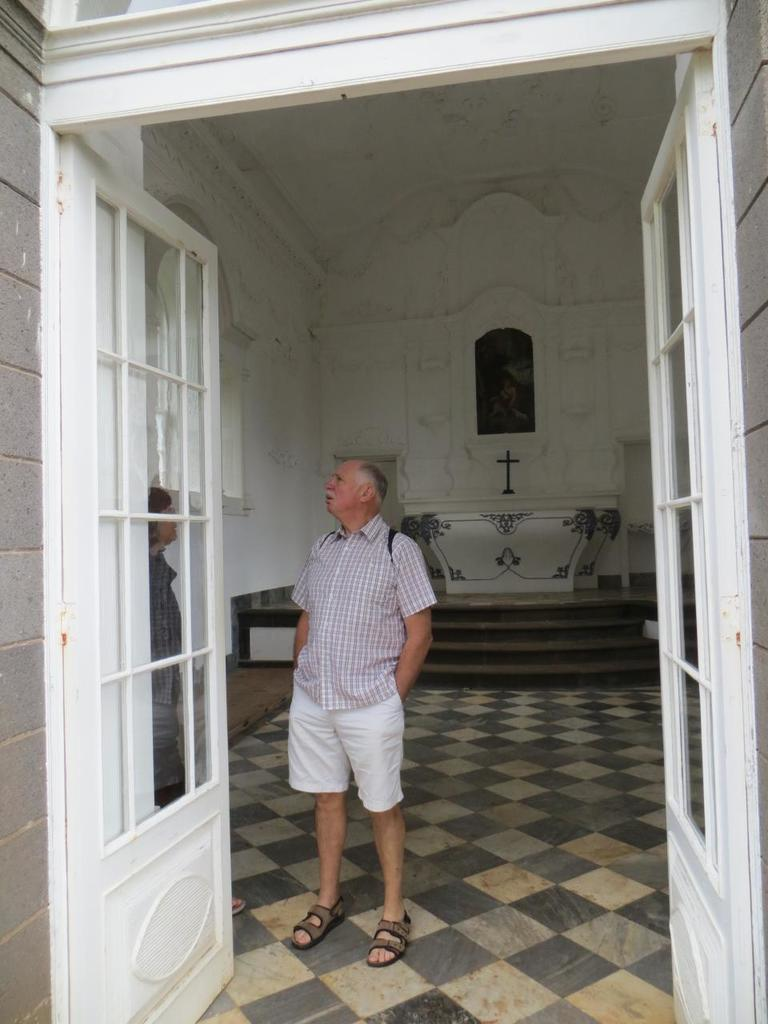What is the main subject of the image? The main subject of the image is the persons standing in the center. What can be seen in the background of the image? In the background of the image, there is a cross, a wall, a table, and a window. Can you describe the foreground of the image? In the foreground of the image, there is a door. How many kittens are sitting on the table in the image? There are no kittens present in the image. Is the queen sitting with the persons in the center of the image? There is no queen present in the image. 